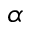<formula> <loc_0><loc_0><loc_500><loc_500>\alpha</formula> 